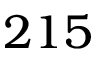<formula> <loc_0><loc_0><loc_500><loc_500>2 1 5</formula> 